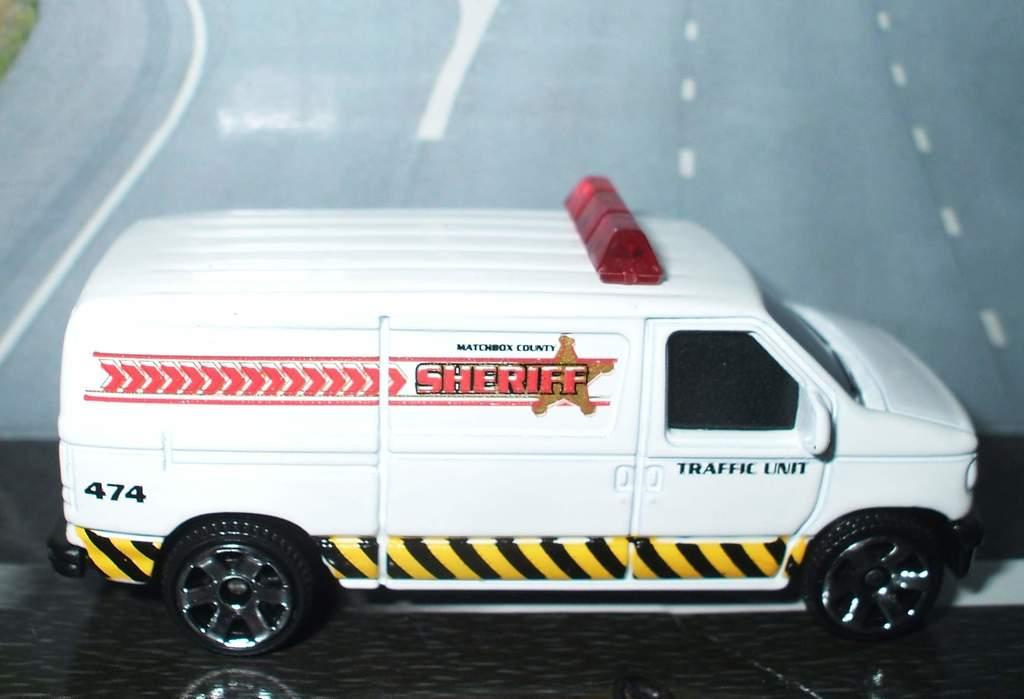<image>
Summarize the visual content of the image. A vehicle has the word Sheriff on the side in red letters. 